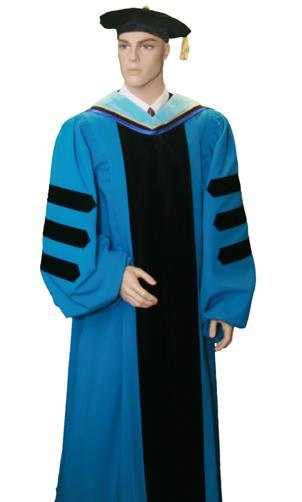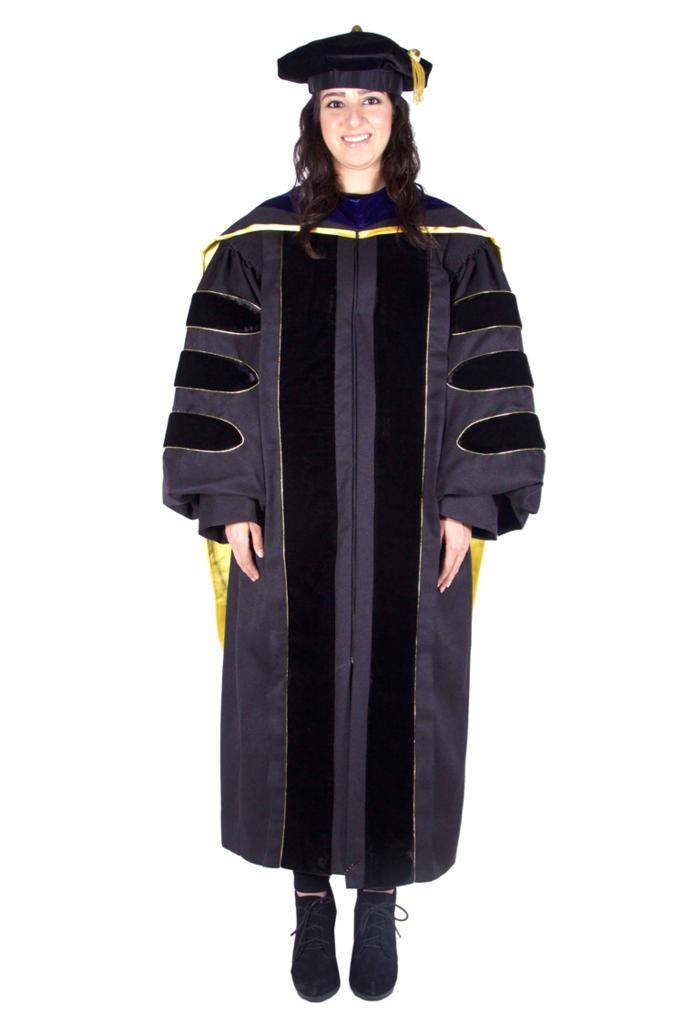The first image is the image on the left, the second image is the image on the right. Evaluate the accuracy of this statement regarding the images: "One image shows a graduation outfit modeled by a real man, and the other image contains at least one graduation robe on a headless mannequin form.". Is it true? Answer yes or no. No. 